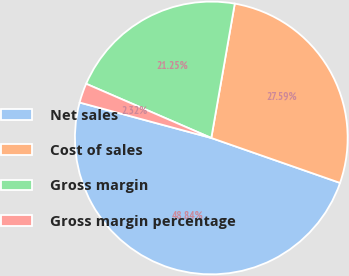Convert chart to OTSL. <chart><loc_0><loc_0><loc_500><loc_500><pie_chart><fcel>Net sales<fcel>Cost of sales<fcel>Gross margin<fcel>Gross margin percentage<nl><fcel>48.84%<fcel>27.59%<fcel>21.25%<fcel>2.32%<nl></chart> 